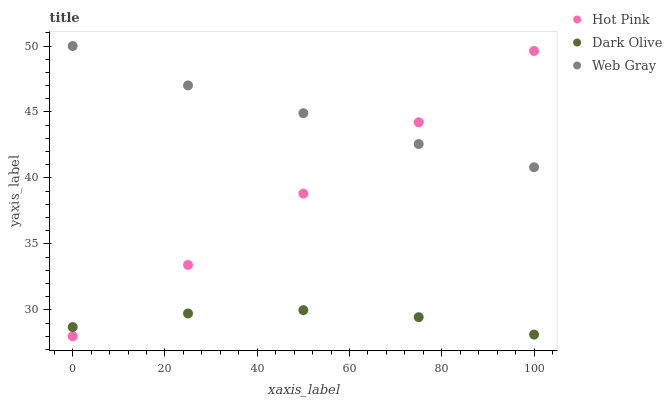Does Dark Olive have the minimum area under the curve?
Answer yes or no. Yes. Does Web Gray have the maximum area under the curve?
Answer yes or no. Yes. Does Hot Pink have the minimum area under the curve?
Answer yes or no. No. Does Hot Pink have the maximum area under the curve?
Answer yes or no. No. Is Hot Pink the smoothest?
Answer yes or no. Yes. Is Dark Olive the roughest?
Answer yes or no. Yes. Is Web Gray the smoothest?
Answer yes or no. No. Is Web Gray the roughest?
Answer yes or no. No. Does Hot Pink have the lowest value?
Answer yes or no. Yes. Does Web Gray have the lowest value?
Answer yes or no. No. Does Web Gray have the highest value?
Answer yes or no. Yes. Does Hot Pink have the highest value?
Answer yes or no. No. Is Dark Olive less than Web Gray?
Answer yes or no. Yes. Is Web Gray greater than Dark Olive?
Answer yes or no. Yes. Does Hot Pink intersect Web Gray?
Answer yes or no. Yes. Is Hot Pink less than Web Gray?
Answer yes or no. No. Is Hot Pink greater than Web Gray?
Answer yes or no. No. Does Dark Olive intersect Web Gray?
Answer yes or no. No. 